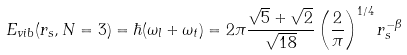<formula> <loc_0><loc_0><loc_500><loc_500>E _ { v i b } ( r _ { s } , N = 3 ) = \hbar { ( } \omega _ { l } + \omega _ { t } ) = 2 \pi \frac { \sqrt { 5 } + \sqrt { 2 } } { \sqrt { 1 8 } } \left ( \frac { 2 } { \pi } \right ) ^ { 1 / 4 } r _ { s } ^ { - \beta }</formula> 